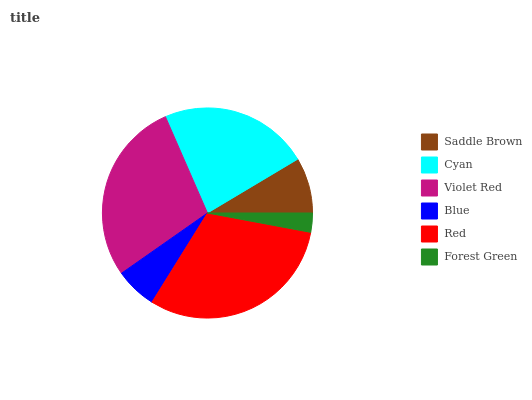Is Forest Green the minimum?
Answer yes or no. Yes. Is Red the maximum?
Answer yes or no. Yes. Is Cyan the minimum?
Answer yes or no. No. Is Cyan the maximum?
Answer yes or no. No. Is Cyan greater than Saddle Brown?
Answer yes or no. Yes. Is Saddle Brown less than Cyan?
Answer yes or no. Yes. Is Saddle Brown greater than Cyan?
Answer yes or no. No. Is Cyan less than Saddle Brown?
Answer yes or no. No. Is Cyan the high median?
Answer yes or no. Yes. Is Saddle Brown the low median?
Answer yes or no. Yes. Is Violet Red the high median?
Answer yes or no. No. Is Blue the low median?
Answer yes or no. No. 